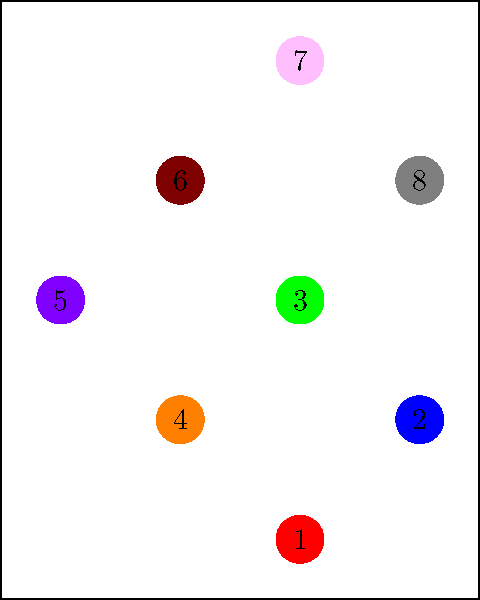In the spatial sequence shown above, colored circles are numbered in the order they should be selected. If a participant correctly replicates this sequence, which two consecutive selections would involve the greatest Euclidean distance between them? To solve this problem, we need to follow these steps:

1. Identify the coordinates of each numbered circle:
   1: (0,0)
   2: (1,1)
   3: (0,2)
   4: (-1,1)
   5: (-2,2)
   6: (-1,3)
   7: (0,4)
   8: (1,3)

2. Calculate the Euclidean distance between consecutive pairs using the formula:
   $d = \sqrt{(x_2-x_1)^2 + (y_2-y_1)^2}$

3. Distances between consecutive pairs:
   1-2: $\sqrt{(1-0)^2 + (1-0)^2} = \sqrt{2}$
   2-3: $\sqrt{(0-1)^2 + (2-1)^2} = \sqrt{2}$
   3-4: $\sqrt{(-1-0)^2 + (1-2)^2} = \sqrt{2}$
   4-5: $\sqrt{(-2+1)^2 + (2-1)^2} = \sqrt{2}$
   5-6: $\sqrt{(-1+2)^2 + (3-2)^2} = \sqrt{2}$
   6-7: $\sqrt{(0+1)^2 + (4-3)^2} = \sqrt{2}$
   7-8: $\sqrt{(1-0)^2 + (3-4)^2} = \sqrt{2}$

4. Observe that all consecutive pairs have the same Euclidean distance of $\sqrt{2}$.

5. Since all consecutive pairs have the same distance, we can choose any pair as the answer. Let's select the first pair (1-2) for consistency.
Answer: 1-2 